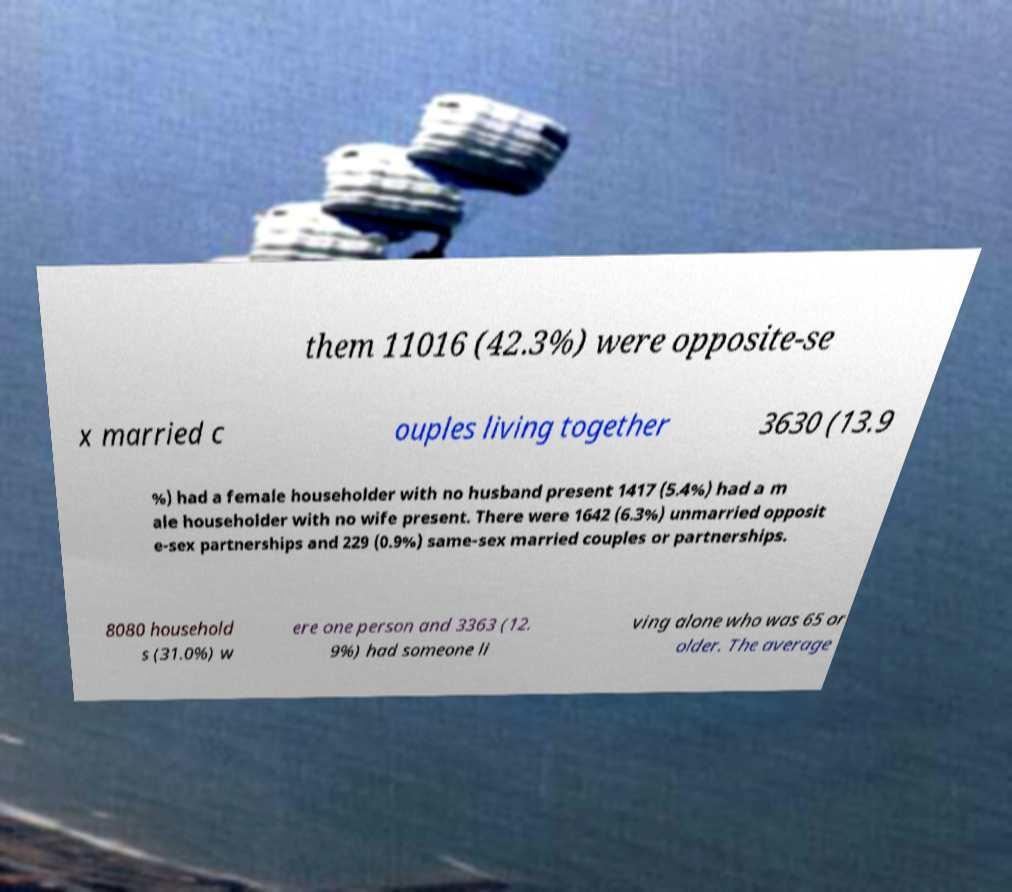Could you extract and type out the text from this image? them 11016 (42.3%) were opposite-se x married c ouples living together 3630 (13.9 %) had a female householder with no husband present 1417 (5.4%) had a m ale householder with no wife present. There were 1642 (6.3%) unmarried opposit e-sex partnerships and 229 (0.9%) same-sex married couples or partnerships. 8080 household s (31.0%) w ere one person and 3363 (12. 9%) had someone li ving alone who was 65 or older. The average 